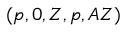<formula> <loc_0><loc_0><loc_500><loc_500>( p , 0 , Z , p , A Z )</formula> 